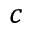<formula> <loc_0><loc_0><loc_500><loc_500>c</formula> 